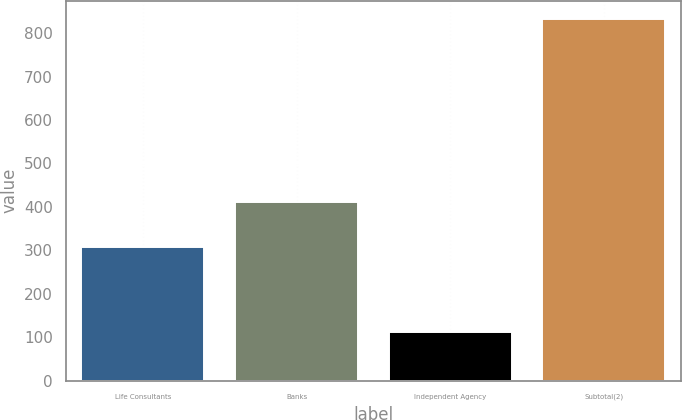Convert chart to OTSL. <chart><loc_0><loc_0><loc_500><loc_500><bar_chart><fcel>Life Consultants<fcel>Banks<fcel>Independent Agency<fcel>Subtotal(2)<nl><fcel>308<fcel>412<fcel>113<fcel>833<nl></chart> 